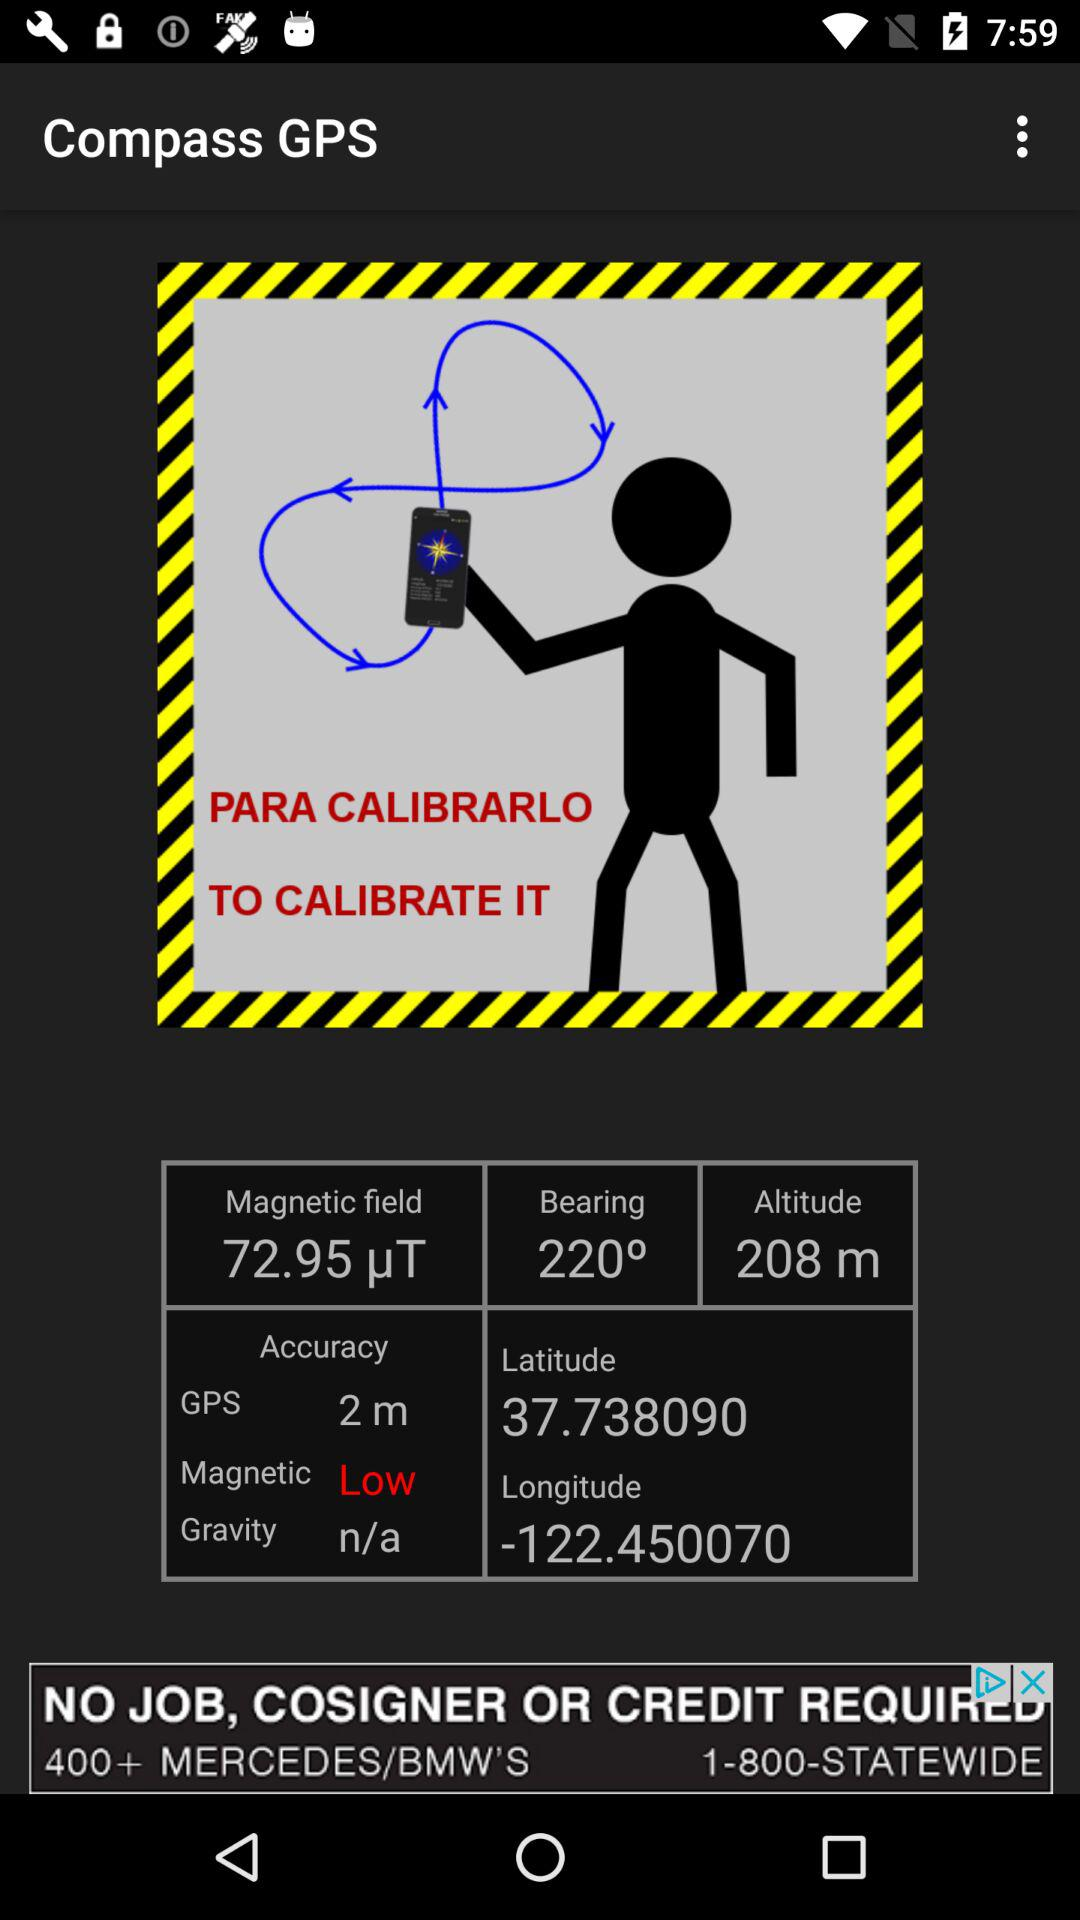What is the magnetic accuracy? The magnetic accuracy is low. 